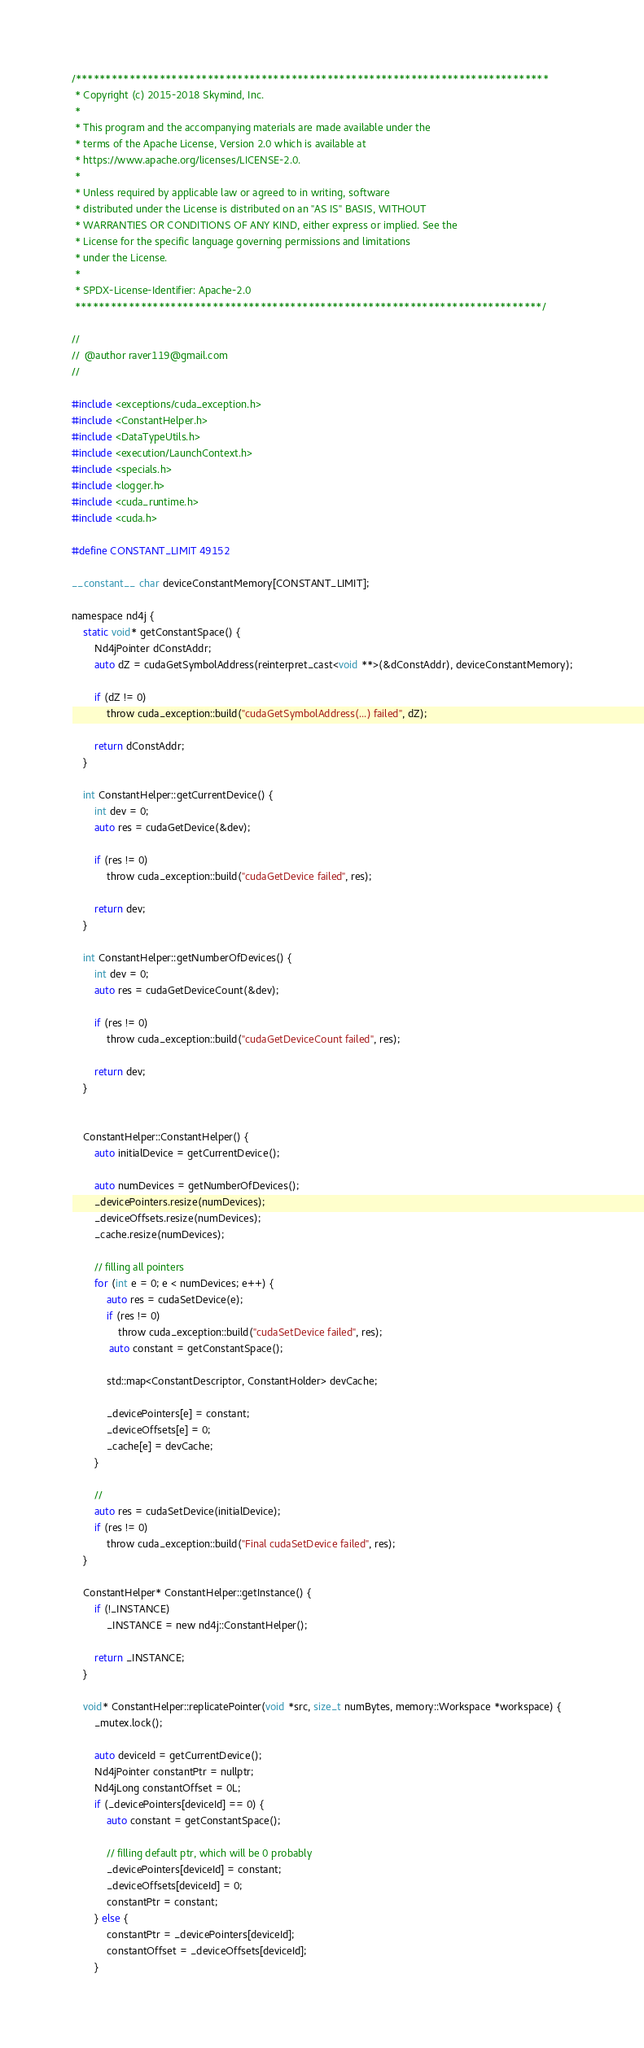<code> <loc_0><loc_0><loc_500><loc_500><_Cuda_>/*******************************************************************************
 * Copyright (c) 2015-2018 Skymind, Inc.
 *
 * This program and the accompanying materials are made available under the
 * terms of the Apache License, Version 2.0 which is available at
 * https://www.apache.org/licenses/LICENSE-2.0.
 *
 * Unless required by applicable law or agreed to in writing, software
 * distributed under the License is distributed on an "AS IS" BASIS, WITHOUT
 * WARRANTIES OR CONDITIONS OF ANY KIND, either express or implied. See the
 * License for the specific language governing permissions and limitations
 * under the License.
 *
 * SPDX-License-Identifier: Apache-2.0
 ******************************************************************************/

//
//  @author raver119@gmail.com
//

#include <exceptions/cuda_exception.h>
#include <ConstantHelper.h>
#include <DataTypeUtils.h>
#include <execution/LaunchContext.h>
#include <specials.h>
#include <logger.h>
#include <cuda_runtime.h>
#include <cuda.h>

#define CONSTANT_LIMIT 49152

__constant__ char deviceConstantMemory[CONSTANT_LIMIT];

namespace nd4j {
    static void* getConstantSpace() {
        Nd4jPointer dConstAddr;
        auto dZ = cudaGetSymbolAddress(reinterpret_cast<void **>(&dConstAddr), deviceConstantMemory);

        if (dZ != 0)
            throw cuda_exception::build("cudaGetSymbolAddress(...) failed", dZ);

        return dConstAddr;
    }

    int ConstantHelper::getCurrentDevice() {
        int dev = 0;
        auto res = cudaGetDevice(&dev);

        if (res != 0)
            throw cuda_exception::build("cudaGetDevice failed", res);

        return dev;
    }

    int ConstantHelper::getNumberOfDevices() {
        int dev = 0;
        auto res = cudaGetDeviceCount(&dev);

        if (res != 0)
            throw cuda_exception::build("cudaGetDeviceCount failed", res);

        return dev;
    }


    ConstantHelper::ConstantHelper() {
        auto initialDevice = getCurrentDevice();

        auto numDevices = getNumberOfDevices();
        _devicePointers.resize(numDevices);
        _deviceOffsets.resize(numDevices);
        _cache.resize(numDevices);

        // filling all pointers
        for (int e = 0; e < numDevices; e++) {
            auto res = cudaSetDevice(e);
            if (res != 0)
                throw cuda_exception::build("cudaSetDevice failed", res);
             auto constant = getConstantSpace();

            std::map<ConstantDescriptor, ConstantHolder> devCache;

            _devicePointers[e] = constant;
            _deviceOffsets[e] = 0;
            _cache[e] = devCache;
        }

        //
        auto res = cudaSetDevice(initialDevice);
        if (res != 0)
            throw cuda_exception::build("Final cudaSetDevice failed", res);
    }

    ConstantHelper* ConstantHelper::getInstance() {
        if (!_INSTANCE)
            _INSTANCE = new nd4j::ConstantHelper();

        return _INSTANCE;
    }

    void* ConstantHelper::replicatePointer(void *src, size_t numBytes, memory::Workspace *workspace) {
        _mutex.lock();

        auto deviceId = getCurrentDevice();
        Nd4jPointer constantPtr = nullptr;
        Nd4jLong constantOffset = 0L;
        if (_devicePointers[deviceId] == 0) {
            auto constant = getConstantSpace();

            // filling default ptr, which will be 0 probably
            _devicePointers[deviceId] = constant;
            _deviceOffsets[deviceId] = 0;
            constantPtr = constant;
        } else {
            constantPtr = _devicePointers[deviceId];
            constantOffset = _deviceOffsets[deviceId];
        }</code> 